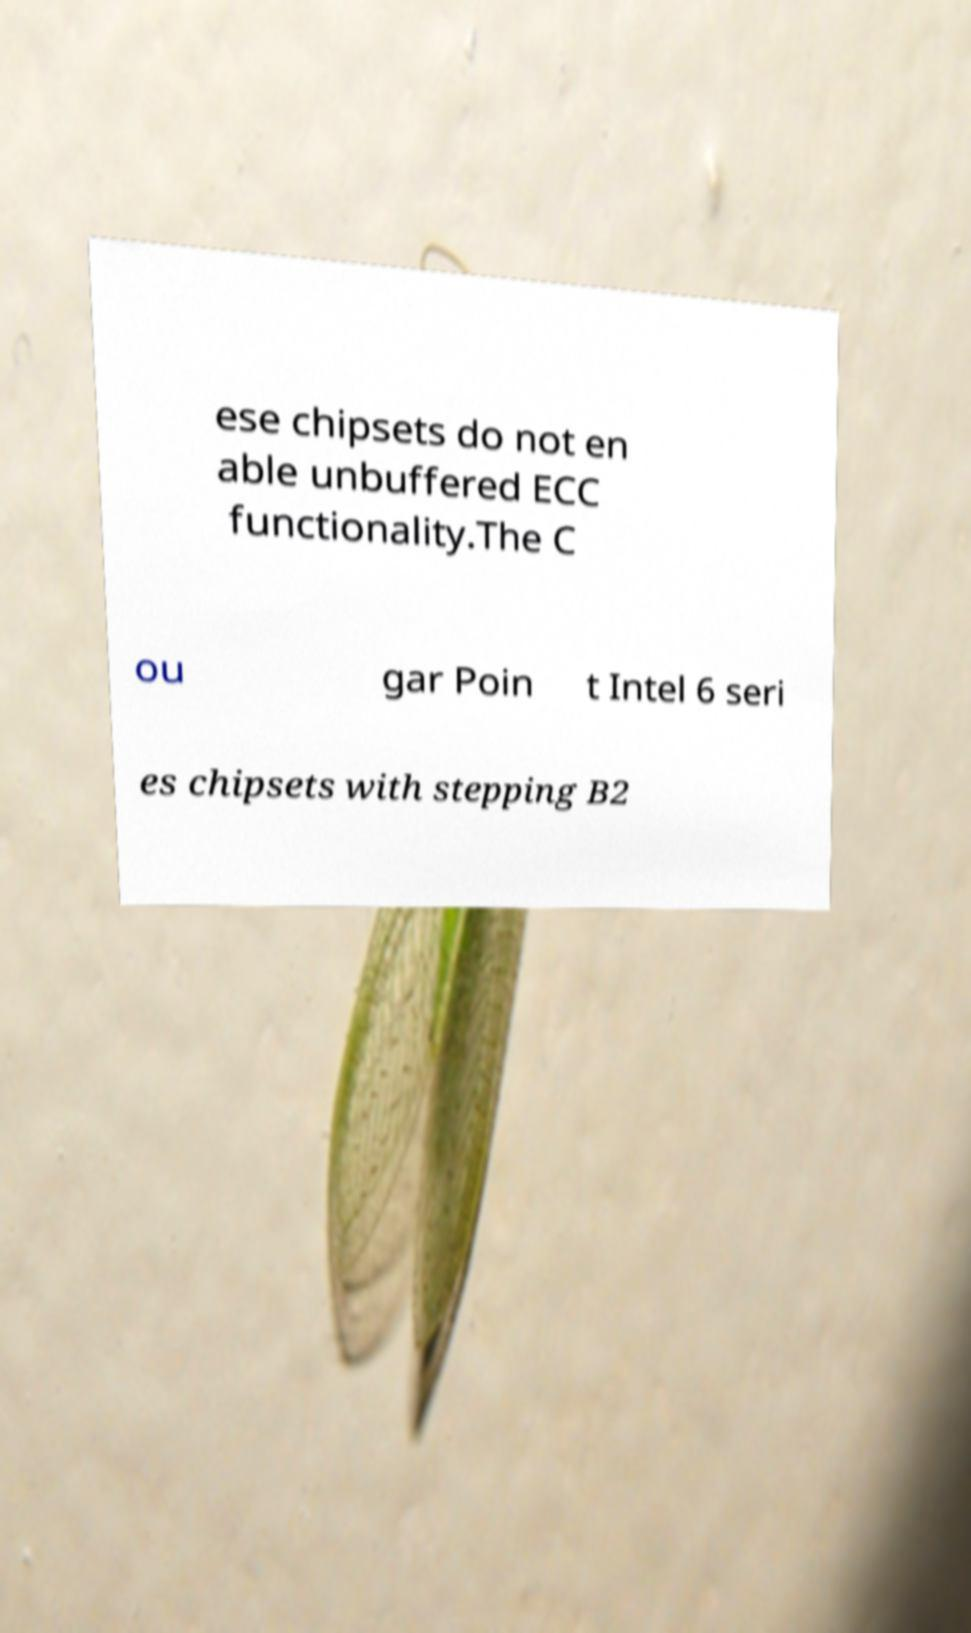I need the written content from this picture converted into text. Can you do that? ese chipsets do not en able unbuffered ECC functionality.The C ou gar Poin t Intel 6 seri es chipsets with stepping B2 